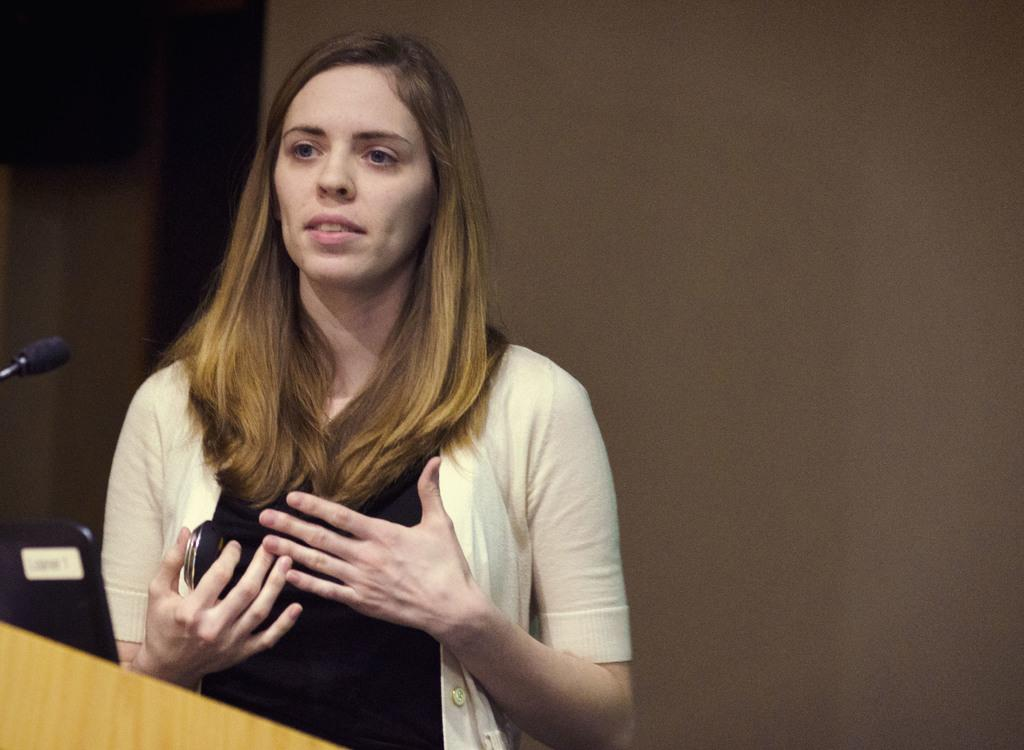Who is the main subject in the image? There is a lady in the image. Where is the lady located in the image? The lady is on the left side of the image. What object is present near the lady? There is a desk in the image. What device is in front of the lady? There is a microphone (mic) in front of the lady. What type of tail can be seen on the lady in the image? There is no tail present on the lady in the image. What is the lady preparing for dinner in the image? The image does not show the lady preparing for dinner or any dinner-related activities. 